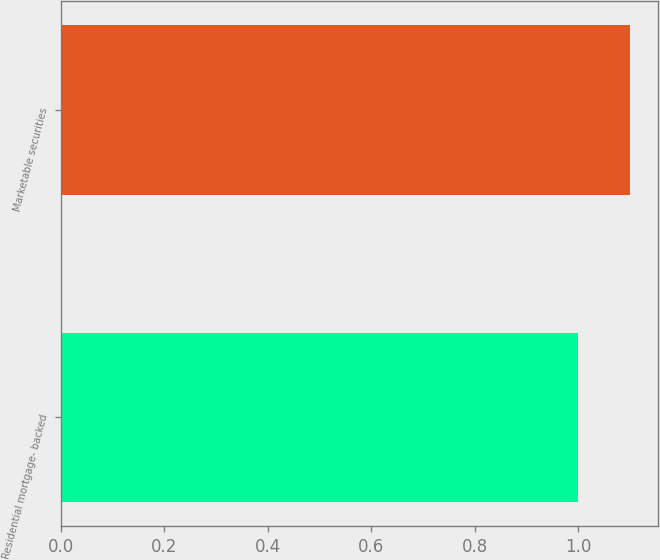<chart> <loc_0><loc_0><loc_500><loc_500><bar_chart><fcel>Residential mortgage- backed<fcel>Marketable securities<nl><fcel>1<fcel>1.1<nl></chart> 